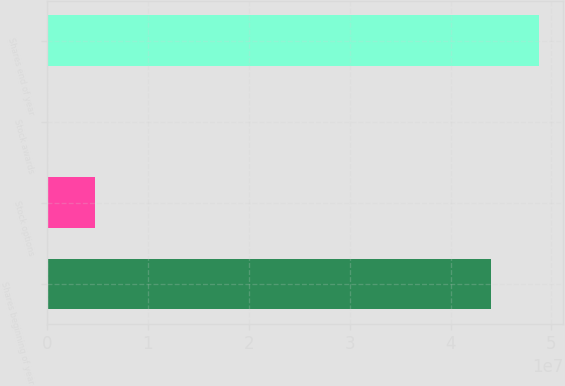Convert chart. <chart><loc_0><loc_0><loc_500><loc_500><bar_chart><fcel>Shares beginning of year<fcel>Stock options<fcel>Stock awards<fcel>Shares end of year<nl><fcel>4.39658e+07<fcel>4.79464e+06<fcel>8231<fcel>4.87522e+07<nl></chart> 